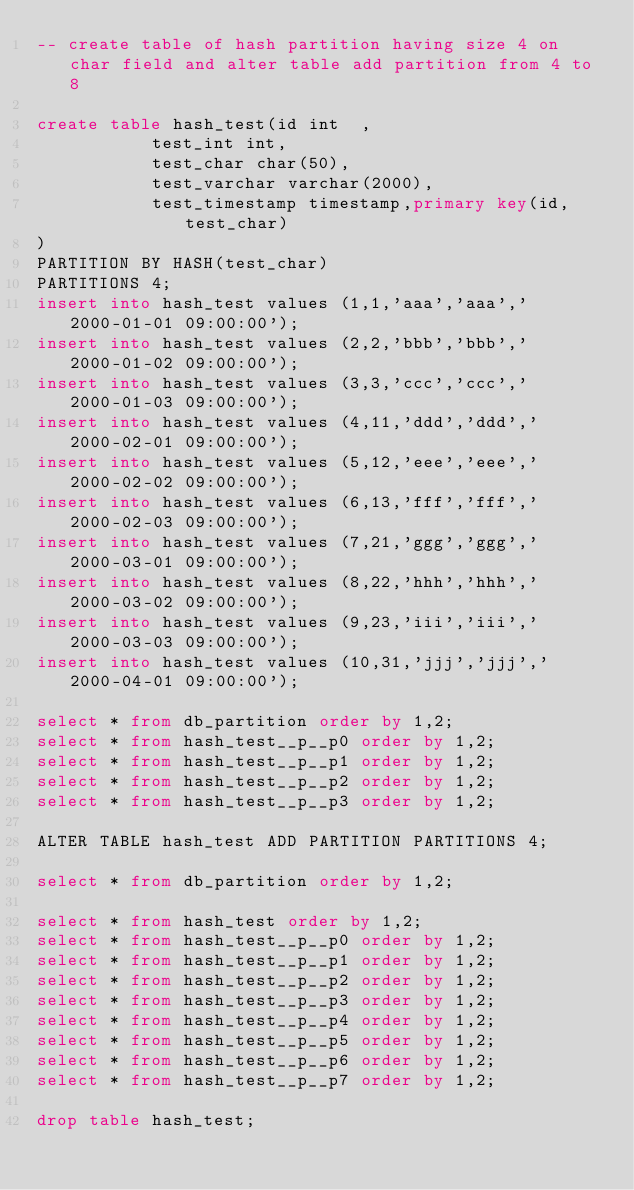<code> <loc_0><loc_0><loc_500><loc_500><_SQL_>-- create table of hash partition having size 4 on char field and alter table add partition from 4 to 8

create table hash_test(id int  ,
		       test_int int,
		       test_char char(50),
		       test_varchar varchar(2000),
		       test_timestamp timestamp,primary key(id,test_char)
)
PARTITION BY HASH(test_char)
PARTITIONS 4;
insert into hash_test values (1,1,'aaa','aaa','2000-01-01 09:00:00');
insert into hash_test values (2,2,'bbb','bbb','2000-01-02 09:00:00');
insert into hash_test values (3,3,'ccc','ccc','2000-01-03 09:00:00');
insert into hash_test values (4,11,'ddd','ddd','2000-02-01 09:00:00');
insert into hash_test values (5,12,'eee','eee','2000-02-02 09:00:00');
insert into hash_test values (6,13,'fff','fff','2000-02-03 09:00:00');
insert into hash_test values (7,21,'ggg','ggg','2000-03-01 09:00:00');
insert into hash_test values (8,22,'hhh','hhh','2000-03-02 09:00:00');
insert into hash_test values (9,23,'iii','iii','2000-03-03 09:00:00');
insert into hash_test values (10,31,'jjj','jjj','2000-04-01 09:00:00');

select * from db_partition order by 1,2;
select * from hash_test__p__p0 order by 1,2;
select * from hash_test__p__p1 order by 1,2;
select * from hash_test__p__p2 order by 1,2;
select * from hash_test__p__p3 order by 1,2;

ALTER TABLE hash_test ADD PARTITION PARTITIONS 4;

select * from db_partition order by 1,2;

select * from hash_test order by 1,2;
select * from hash_test__p__p0 order by 1,2;
select * from hash_test__p__p1 order by 1,2;
select * from hash_test__p__p2 order by 1,2;
select * from hash_test__p__p3 order by 1,2;
select * from hash_test__p__p4 order by 1,2;
select * from hash_test__p__p5 order by 1,2;
select * from hash_test__p__p6 order by 1,2;
select * from hash_test__p__p7 order by 1,2;

drop table hash_test;
</code> 